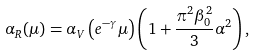<formula> <loc_0><loc_0><loc_500><loc_500>\alpha _ { R } ( \mu ) = \alpha _ { V } \left ( e ^ { - \gamma } \mu \right ) \left ( 1 + \frac { \pi ^ { 2 } \beta _ { 0 } ^ { 2 } } { 3 } \alpha ^ { 2 } \right ) ,</formula> 